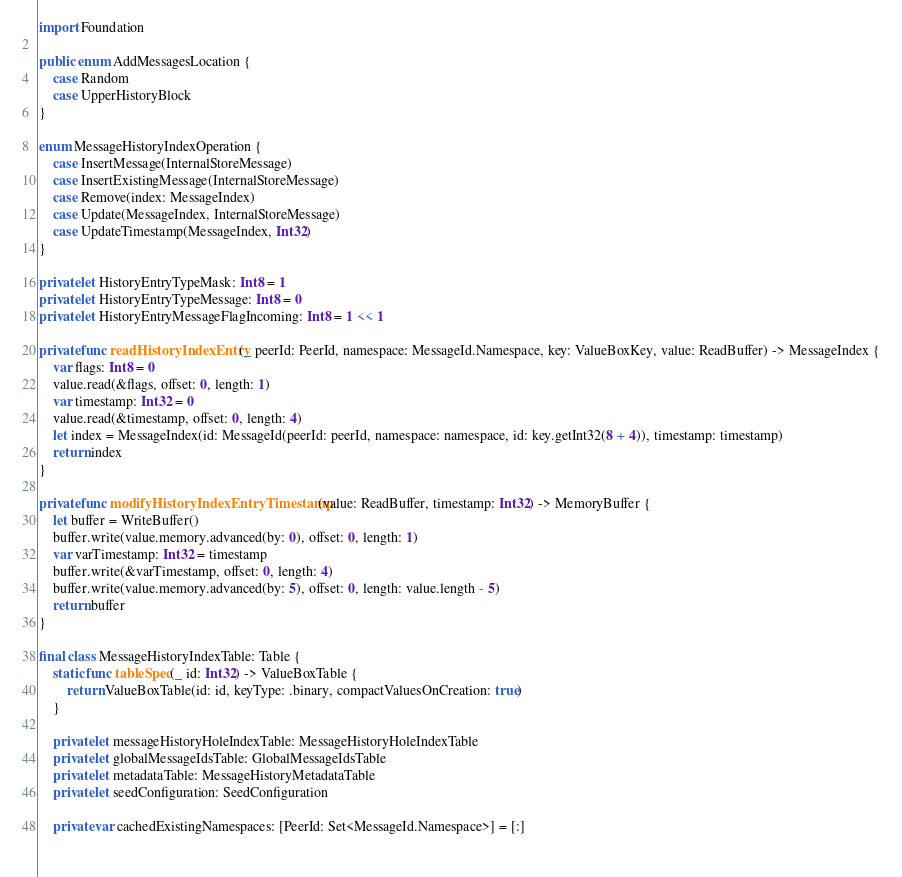<code> <loc_0><loc_0><loc_500><loc_500><_Swift_>import Foundation

public enum AddMessagesLocation {
    case Random
    case UpperHistoryBlock
}

enum MessageHistoryIndexOperation {
    case InsertMessage(InternalStoreMessage)
    case InsertExistingMessage(InternalStoreMessage)
    case Remove(index: MessageIndex)
    case Update(MessageIndex, InternalStoreMessage)
    case UpdateTimestamp(MessageIndex, Int32)
}

private let HistoryEntryTypeMask: Int8 = 1
private let HistoryEntryTypeMessage: Int8 = 0
private let HistoryEntryMessageFlagIncoming: Int8 = 1 << 1

private func readHistoryIndexEntry(_ peerId: PeerId, namespace: MessageId.Namespace, key: ValueBoxKey, value: ReadBuffer) -> MessageIndex {
    var flags: Int8 = 0
    value.read(&flags, offset: 0, length: 1)
    var timestamp: Int32 = 0
    value.read(&timestamp, offset: 0, length: 4)
    let index = MessageIndex(id: MessageId(peerId: peerId, namespace: namespace, id: key.getInt32(8 + 4)), timestamp: timestamp)
    return index
}

private func modifyHistoryIndexEntryTimestamp(value: ReadBuffer, timestamp: Int32) -> MemoryBuffer {
    let buffer = WriteBuffer()
    buffer.write(value.memory.advanced(by: 0), offset: 0, length: 1)
    var varTimestamp: Int32 = timestamp
    buffer.write(&varTimestamp, offset: 0, length: 4)
    buffer.write(value.memory.advanced(by: 5), offset: 0, length: value.length - 5)
    return buffer
}

final class MessageHistoryIndexTable: Table {
    static func tableSpec(_ id: Int32) -> ValueBoxTable {
        return ValueBoxTable(id: id, keyType: .binary, compactValuesOnCreation: true)
    }
    
    private let messageHistoryHoleIndexTable: MessageHistoryHoleIndexTable
    private let globalMessageIdsTable: GlobalMessageIdsTable
    private let metadataTable: MessageHistoryMetadataTable
    private let seedConfiguration: SeedConfiguration
    
    private var cachedExistingNamespaces: [PeerId: Set<MessageId.Namespace>] = [:]
    </code> 